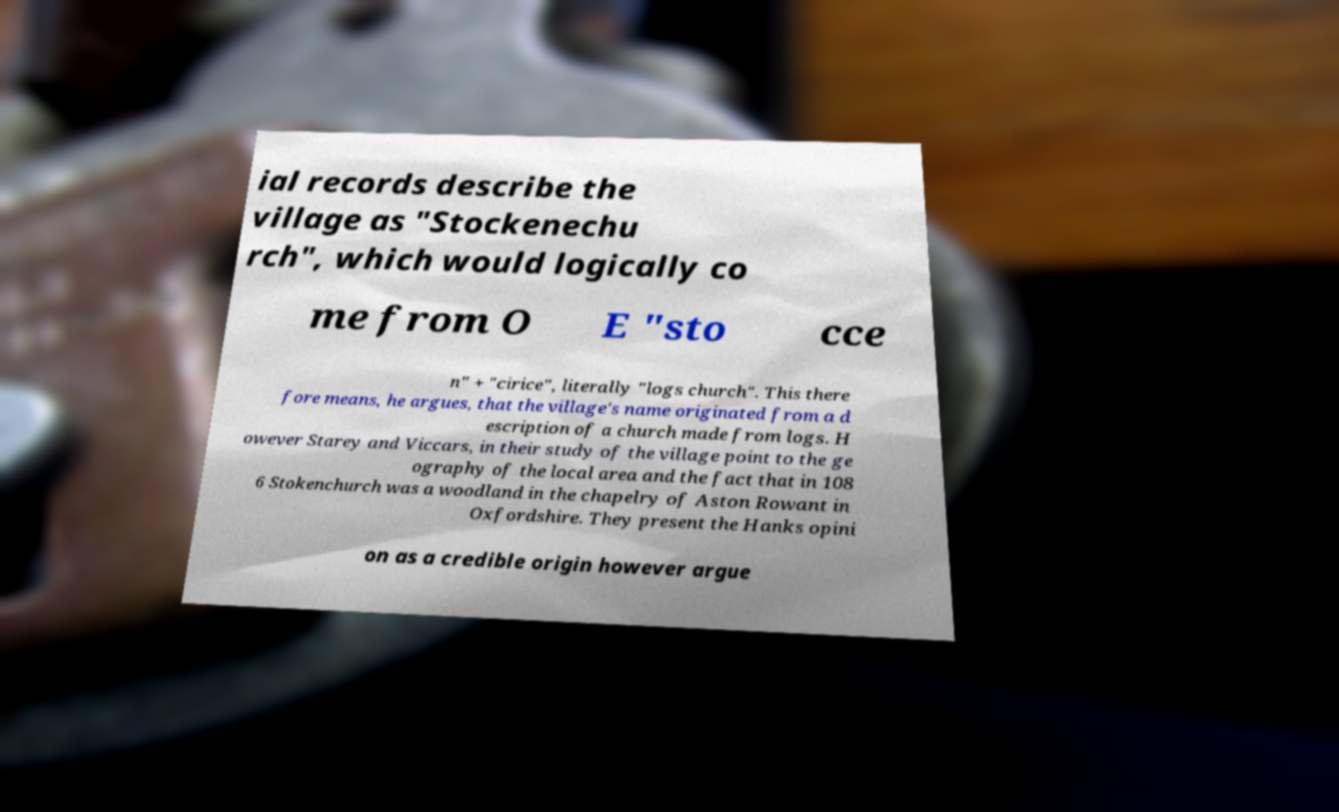Please read and relay the text visible in this image. What does it say? ial records describe the village as "Stockenechu rch", which would logically co me from O E "sto cce n" + "cirice", literally "logs church". This there fore means, he argues, that the village's name originated from a d escription of a church made from logs. H owever Starey and Viccars, in their study of the village point to the ge ography of the local area and the fact that in 108 6 Stokenchurch was a woodland in the chapelry of Aston Rowant in Oxfordshire. They present the Hanks opini on as a credible origin however argue 